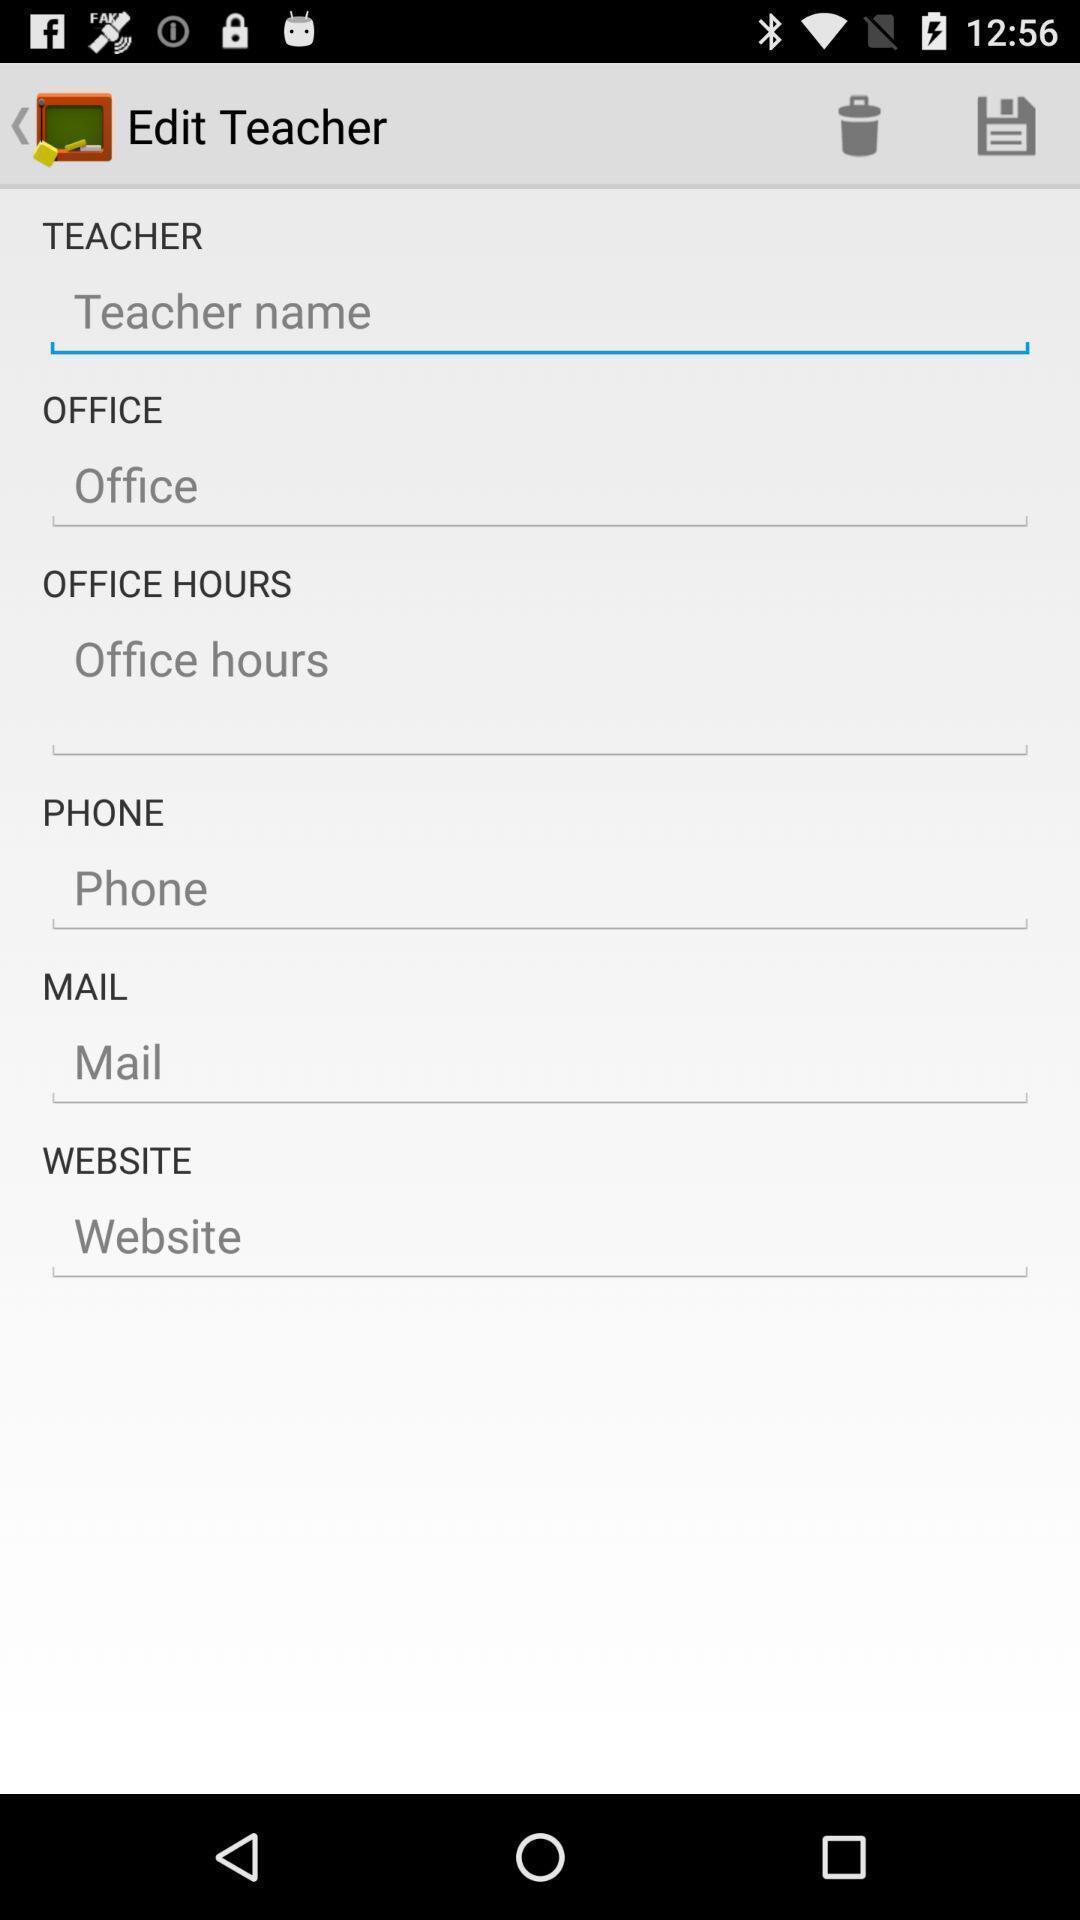Describe the key features of this screenshot. Page showing information about teacher. 